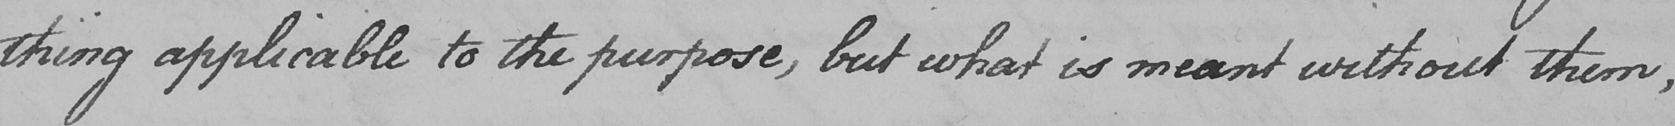Please provide the text content of this handwritten line. -thing applicable to the purpose , but what is meant without them , 